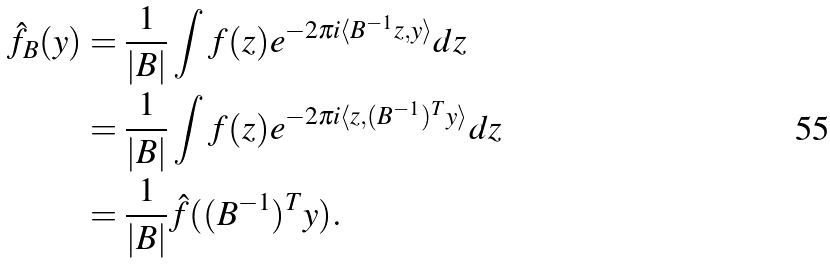<formula> <loc_0><loc_0><loc_500><loc_500>\hat { f } _ { B } ( y ) & = \frac { 1 } { | B | } \int f ( z ) e ^ { - 2 \pi i \langle B ^ { - 1 } z , y \rangle } d z \\ & = \frac { 1 } { | B | } \int f ( z ) e ^ { - 2 \pi i \langle z , ( B ^ { - 1 } ) ^ { T } y \rangle } d z \\ & = \frac { 1 } { | B | } \hat { f } ( ( B ^ { - 1 } ) ^ { T } y ) .</formula> 